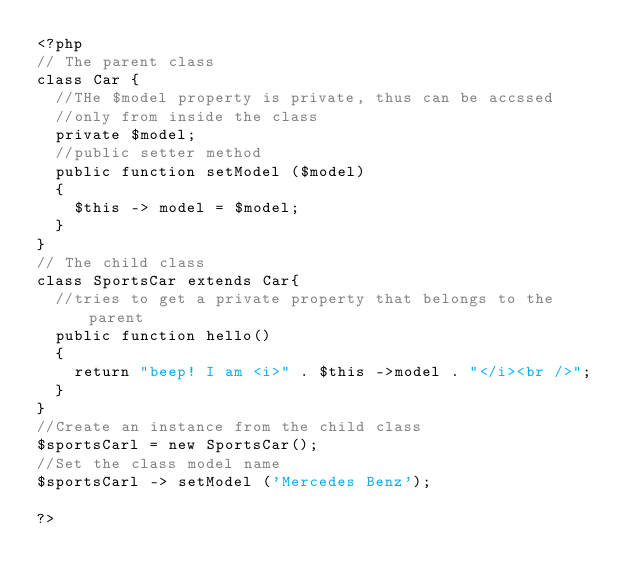<code> <loc_0><loc_0><loc_500><loc_500><_PHP_><?php
// The parent class
class Car {
	//THe $model property is private, thus can be accssed
	//only from inside the class
	private $model;
	//public setter method
	public function setModel ($model)
	{
		$this -> model = $model;
	}
}
// The child class
class SportsCar extends Car{
	//tries to get a private property that belongs to the parent
	public function hello()
	{
		return "beep! I am <i>" . $this ->model . "</i><br />";
	}
}
//Create an instance from the child class
$sportsCarl = new SportsCar();
//Set the class model name
$sportsCarl -> setModel ('Mercedes Benz');

?></code> 